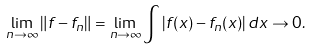Convert formula to latex. <formula><loc_0><loc_0><loc_500><loc_500>\lim _ { n \rightarrow \infty } \| f - f _ { n } \| = \lim _ { n \rightarrow \infty } \int \left | f ( x ) - f _ { n } ( x ) \right | d x \rightarrow 0 .</formula> 